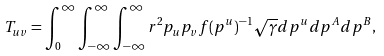<formula> <loc_0><loc_0><loc_500><loc_500>T _ { u v } = \int _ { 0 } ^ { \infty } \int _ { - \infty } ^ { \infty } \int _ { - \infty } ^ { \infty } r ^ { 2 } p _ { u } p _ { v } f ( p ^ { u } ) ^ { - 1 } \sqrt { \gamma } d p ^ { u } d p ^ { A } d p ^ { B } ,</formula> 